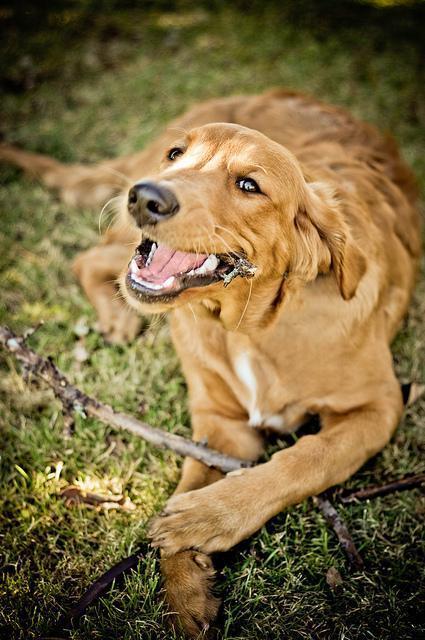How many dogs are seen?
Give a very brief answer. 1. How many dogs are visible?
Give a very brief answer. 2. 